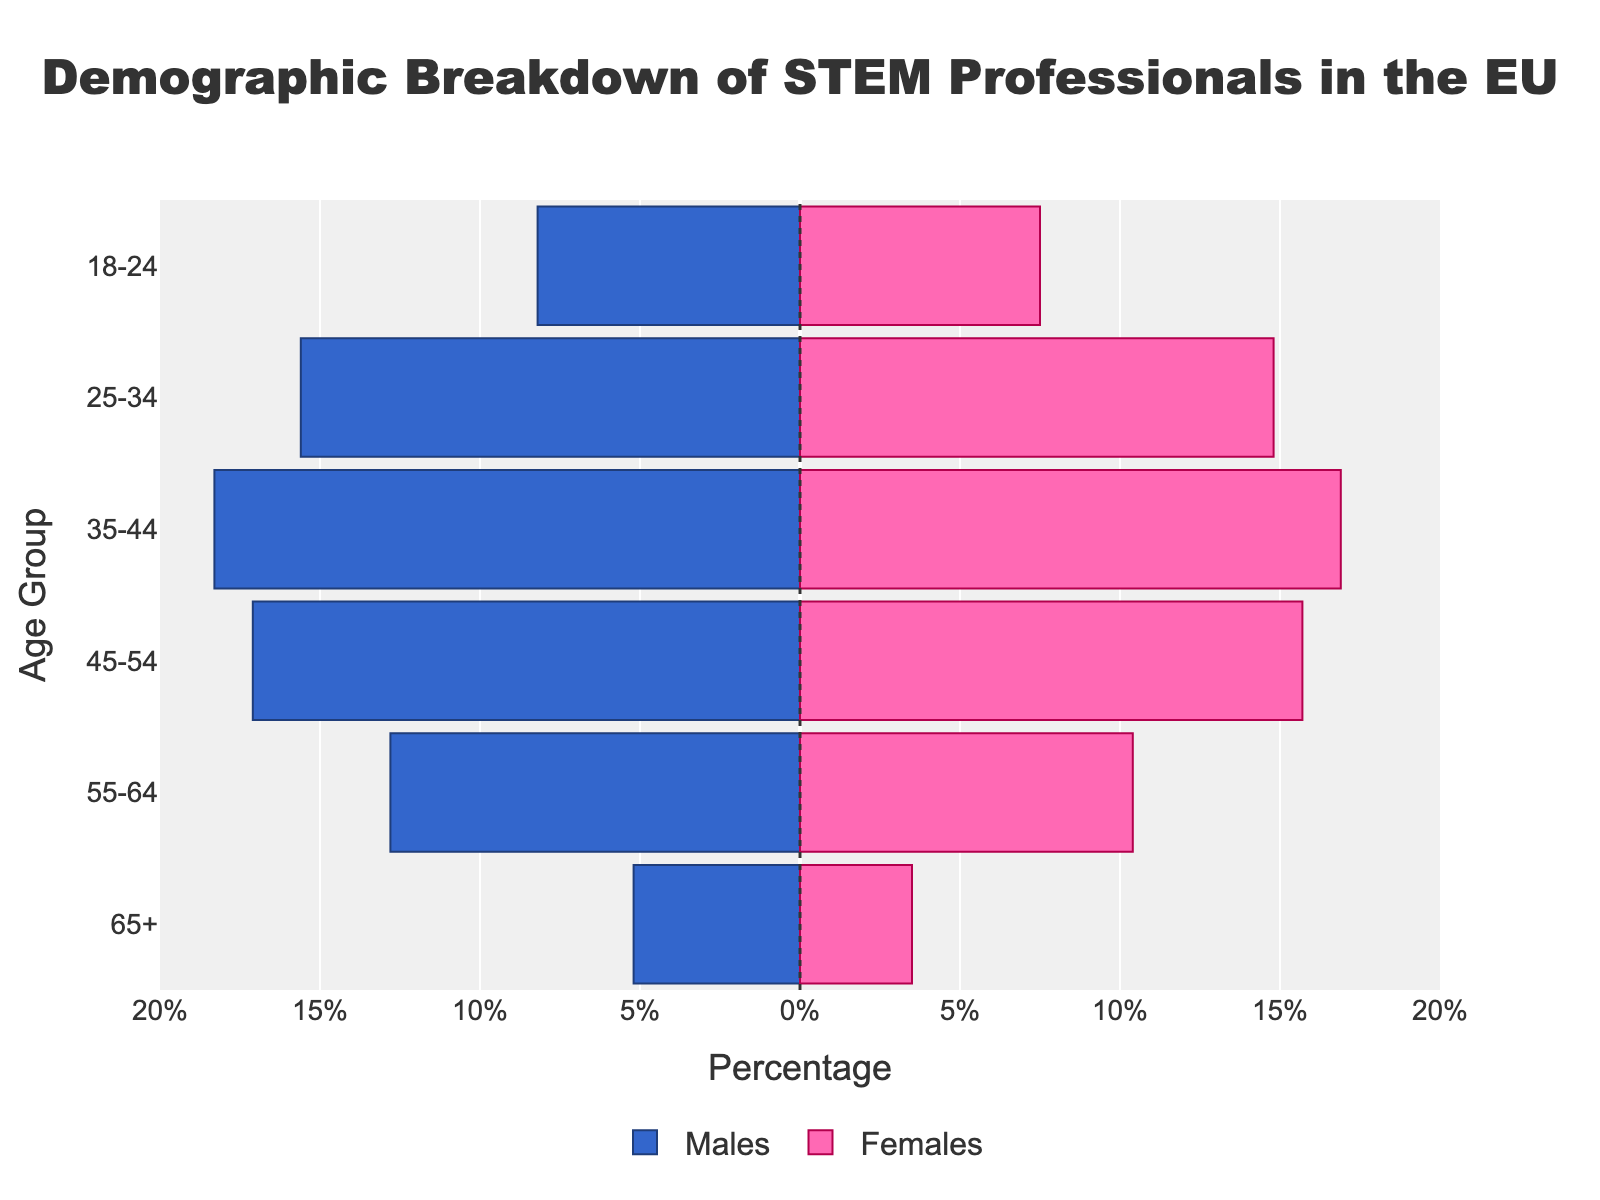What age group has the highest percentage of males in STEM professions? Looking at the male bars, the age group 35-44 has the largest negative bar, indicating the highest percentage at 18.3%.
Answer: 35-44 Which age group has the smallest gender gap in STEM professions? Calculate the percentage difference between males and females for each age group. For 18-24, it's 8.2% - 7.5% = 0.7%. Continue for each group: 25-34 (0.8%), 35-44 (1.4%), 45-54 (1.4%), 55-64 (2.4%), 65+ (1.7%). The smallest gap is 0.7% for 18-24.
Answer: 18-24 What is the combined percentage of STEM professionals aged 55-64? Sum the percentages of males and females in the 55-64 age group: 12.8% (males) + 10.4% (females) = 23.2%.
Answer: 23.2% Compare the percentage of males in the 45-54 age group to that of females. The percentage of males in the 45-54 age group is 17.1%, while for females it's 15.7%. Males have a slightly higher percentage.
Answer: Males have a higher percentage Which side of the vertical line at x=0 do the female bars appear? The bars representing females are on the right side of the vertical line at x=0.
Answer: Right side Is the percentage of females aged 35-44 greater than that of females aged 25-34? The percentage of females aged 35-44 is 16.9%, which is higher than the 14.8% for the 25-34 age group.
Answer: Yes What is the difference in the percentage of males and females aged 65+? Subtract the percentage of females from that of males in the 65+ age group: 5.2% (males) - 3.5% (females) = 1.7%.
Answer: 1.7% How does the bar length for males aged 18-24 compare to that of females aged 18-24? The bar for males aged 18-24 extends to -8.2%, while the bar for females extends to 7.5%. The male bar is slightly longer.
Answer: Male bar is longer 